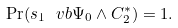Convert formula to latex. <formula><loc_0><loc_0><loc_500><loc_500>\Pr ( s _ { 1 } \ v b \Psi _ { 0 } \land C _ { 2 } ^ { * } ) = 1 .</formula> 